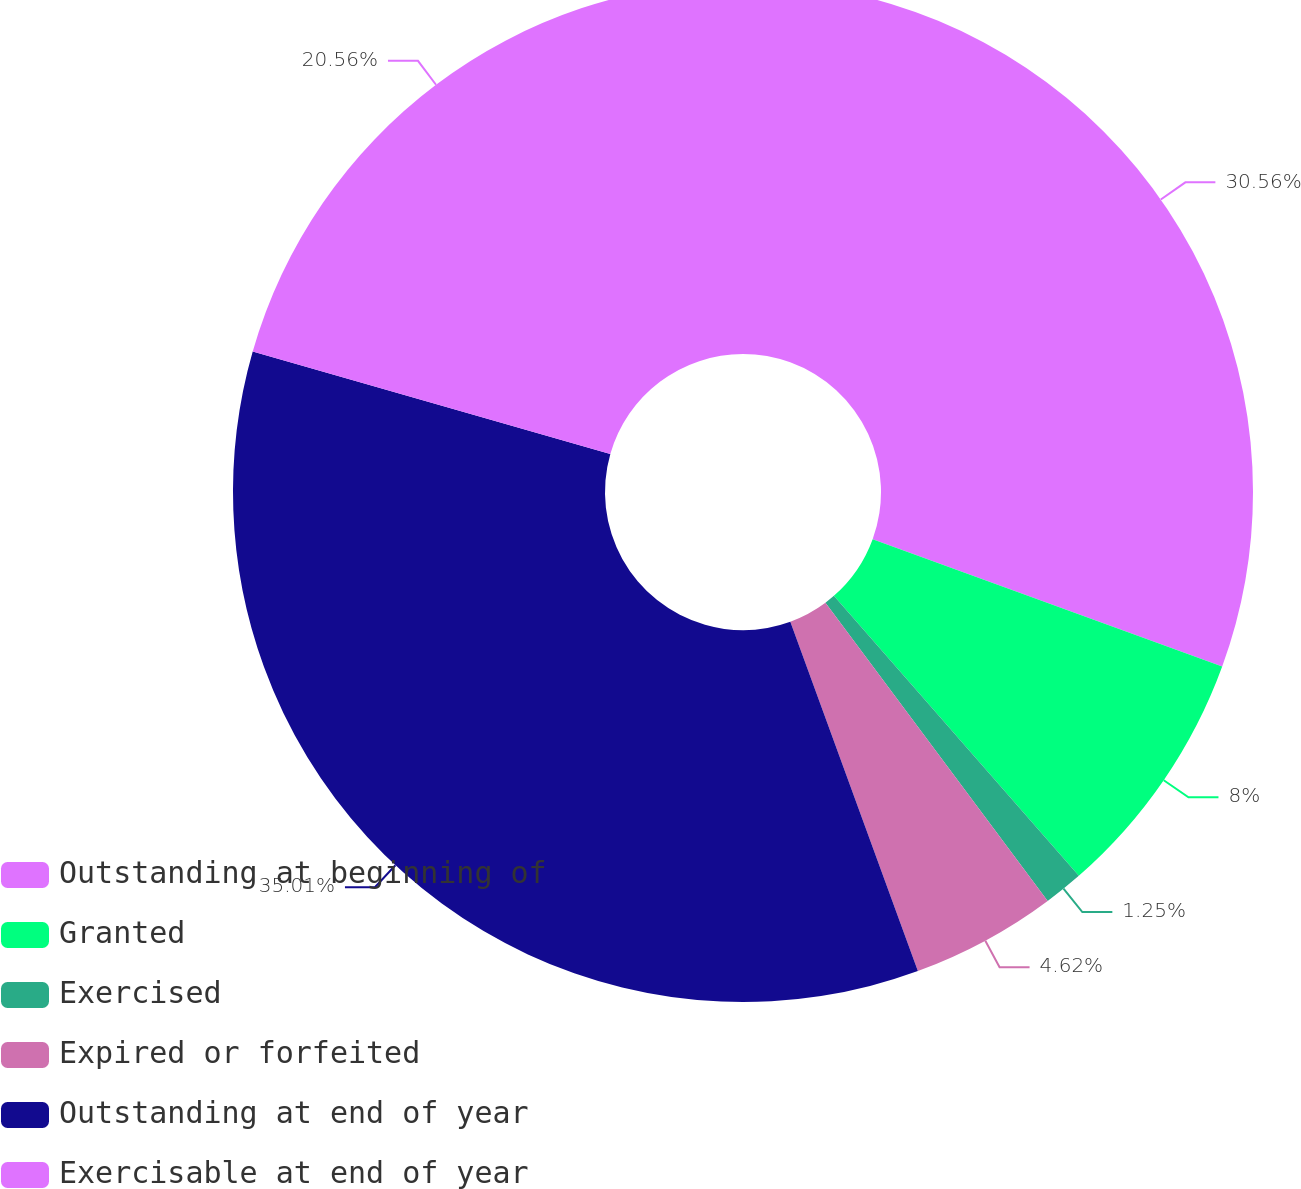Convert chart. <chart><loc_0><loc_0><loc_500><loc_500><pie_chart><fcel>Outstanding at beginning of<fcel>Granted<fcel>Exercised<fcel>Expired or forfeited<fcel>Outstanding at end of year<fcel>Exercisable at end of year<nl><fcel>30.56%<fcel>8.0%<fcel>1.25%<fcel>4.62%<fcel>35.01%<fcel>20.56%<nl></chart> 